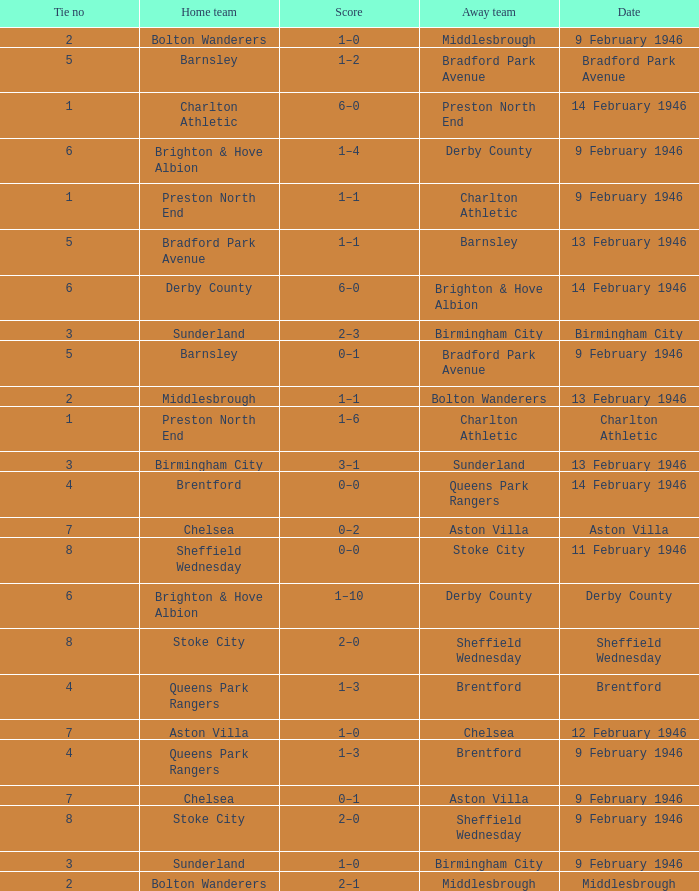What was the Tie no when then home team was Stoke City for the game played on 9 February 1946? 8.0. 